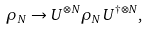Convert formula to latex. <formula><loc_0><loc_0><loc_500><loc_500>\rho _ { N } \rightarrow U ^ { \otimes N } \rho _ { N } U ^ { \dagger \otimes N } ,</formula> 